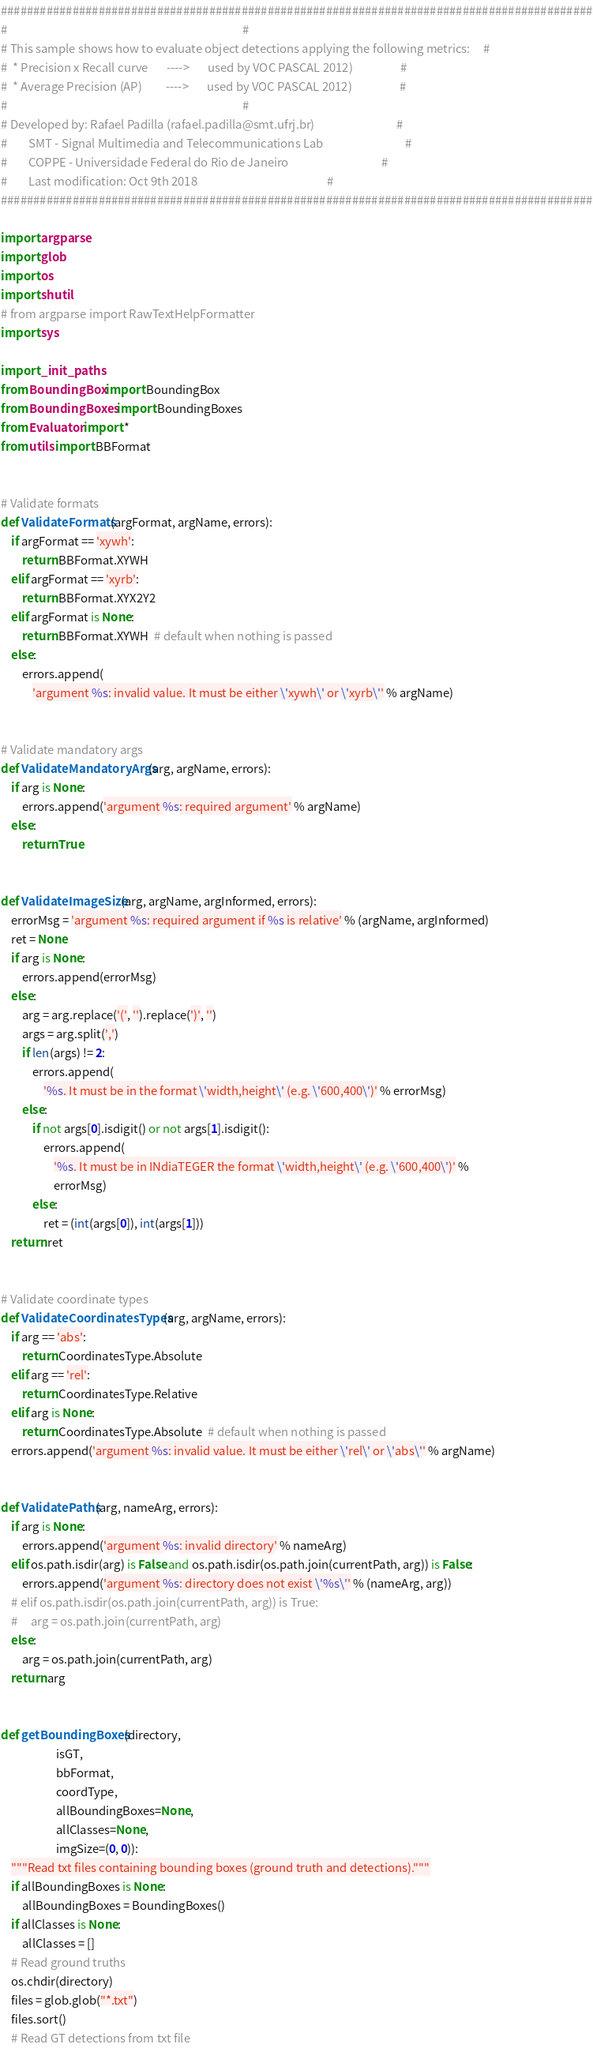<code> <loc_0><loc_0><loc_500><loc_500><_Python_>###########################################################################################
#                                                                                         #
# This sample shows how to evaluate object detections applying the following metrics:     #
#  * Precision x Recall curve       ---->       used by VOC PASCAL 2012)                  #
#  * Average Precision (AP)         ---->       used by VOC PASCAL 2012)                  #
#                                                                                         #
# Developed by: Rafael Padilla (rafael.padilla@smt.ufrj.br)                               #
#        SMT - Signal Multimedia and Telecommunications Lab                               #
#        COPPE - Universidade Federal do Rio de Janeiro                                   #
#        Last modification: Oct 9th 2018                                                 #
###########################################################################################

import argparse
import glob
import os
import shutil
# from argparse import RawTextHelpFormatter
import sys

import _init_paths
from BoundingBox import BoundingBox
from BoundingBoxes import BoundingBoxes
from Evaluator import *
from utils import BBFormat


# Validate formats
def ValidateFormats(argFormat, argName, errors):
    if argFormat == 'xywh':
        return BBFormat.XYWH
    elif argFormat == 'xyrb':
        return BBFormat.XYX2Y2
    elif argFormat is None:
        return BBFormat.XYWH  # default when nothing is passed
    else:
        errors.append(
            'argument %s: invalid value. It must be either \'xywh\' or \'xyrb\'' % argName)


# Validate mandatory args
def ValidateMandatoryArgs(arg, argName, errors):
    if arg is None:
        errors.append('argument %s: required argument' % argName)
    else:
        return True


def ValidateImageSize(arg, argName, argInformed, errors):
    errorMsg = 'argument %s: required argument if %s is relative' % (argName, argInformed)
    ret = None
    if arg is None:
        errors.append(errorMsg)
    else:
        arg = arg.replace('(', '').replace(')', '')
        args = arg.split(',')
        if len(args) != 2:
            errors.append(
                '%s. It must be in the format \'width,height\' (e.g. \'600,400\')' % errorMsg)
        else:
            if not args[0].isdigit() or not args[1].isdigit():
                errors.append(
                    '%s. It must be in INdiaTEGER the format \'width,height\' (e.g. \'600,400\')' %
                    errorMsg)
            else:
                ret = (int(args[0]), int(args[1]))
    return ret


# Validate coordinate types
def ValidateCoordinatesTypes(arg, argName, errors):
    if arg == 'abs':
        return CoordinatesType.Absolute
    elif arg == 'rel':
        return CoordinatesType.Relative
    elif arg is None:
        return CoordinatesType.Absolute  # default when nothing is passed
    errors.append('argument %s: invalid value. It must be either \'rel\' or \'abs\'' % argName)


def ValidatePaths(arg, nameArg, errors):
    if arg is None:
        errors.append('argument %s: invalid directory' % nameArg)
    elif os.path.isdir(arg) is False and os.path.isdir(os.path.join(currentPath, arg)) is False:
        errors.append('argument %s: directory does not exist \'%s\'' % (nameArg, arg))
    # elif os.path.isdir(os.path.join(currentPath, arg)) is True:
    #     arg = os.path.join(currentPath, arg)
    else:
        arg = os.path.join(currentPath, arg)
    return arg


def getBoundingBoxes(directory,
                     isGT,
                     bbFormat,
                     coordType,
                     allBoundingBoxes=None,
                     allClasses=None,
                     imgSize=(0, 0)):
    """Read txt files containing bounding boxes (ground truth and detections)."""
    if allBoundingBoxes is None:
        allBoundingBoxes = BoundingBoxes()
    if allClasses is None:
        allClasses = []
    # Read ground truths
    os.chdir(directory)
    files = glob.glob("*.txt")
    files.sort()
    # Read GT detections from txt file</code> 